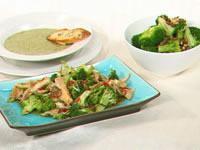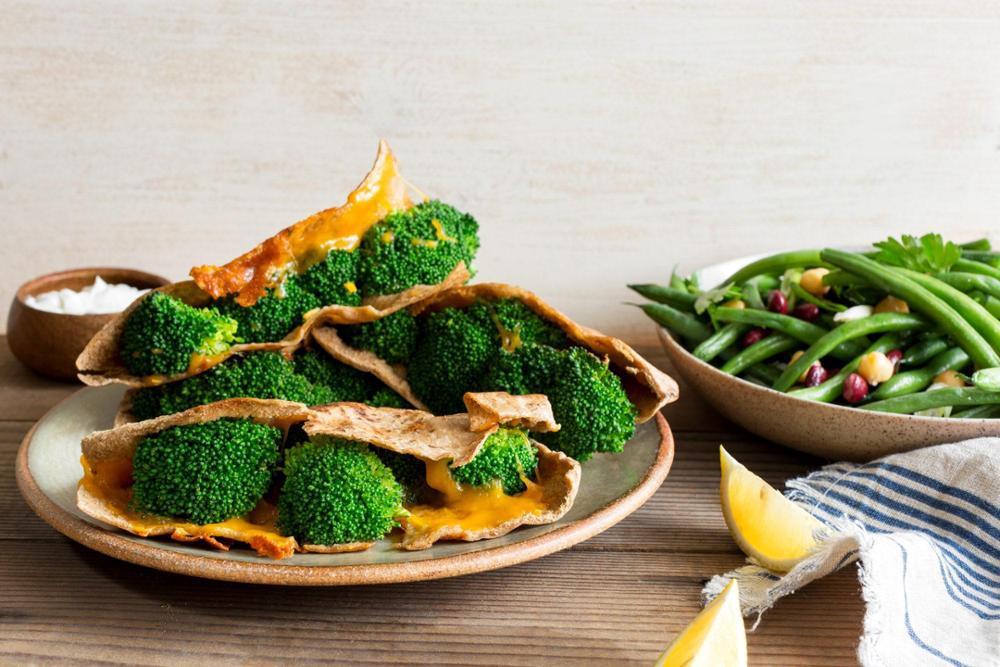The first image is the image on the left, the second image is the image on the right. For the images shown, is this caption "Left image shows food served in a rectangular dish." true? Answer yes or no. Yes. The first image is the image on the left, the second image is the image on the right. For the images displayed, is the sentence "At least one dish has pasta in it." factually correct? Answer yes or no. No. 